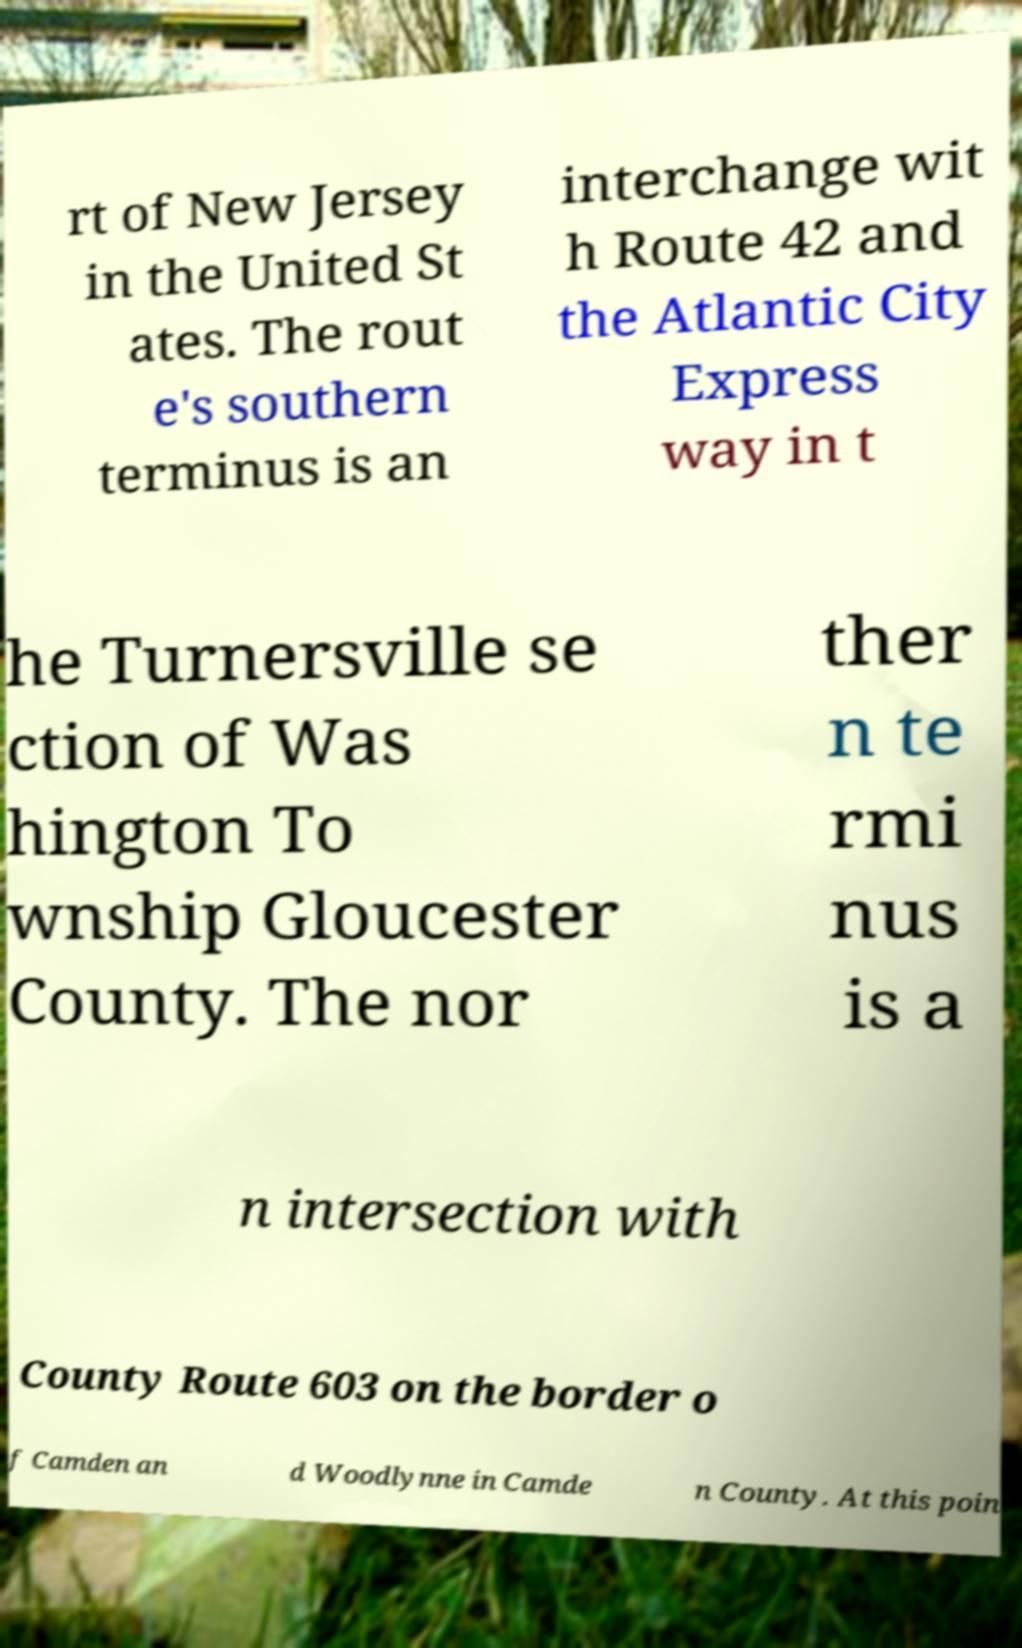There's text embedded in this image that I need extracted. Can you transcribe it verbatim? rt of New Jersey in the United St ates. The rout e's southern terminus is an interchange wit h Route 42 and the Atlantic City Express way in t he Turnersville se ction of Was hington To wnship Gloucester County. The nor ther n te rmi nus is a n intersection with County Route 603 on the border o f Camden an d Woodlynne in Camde n County. At this poin 